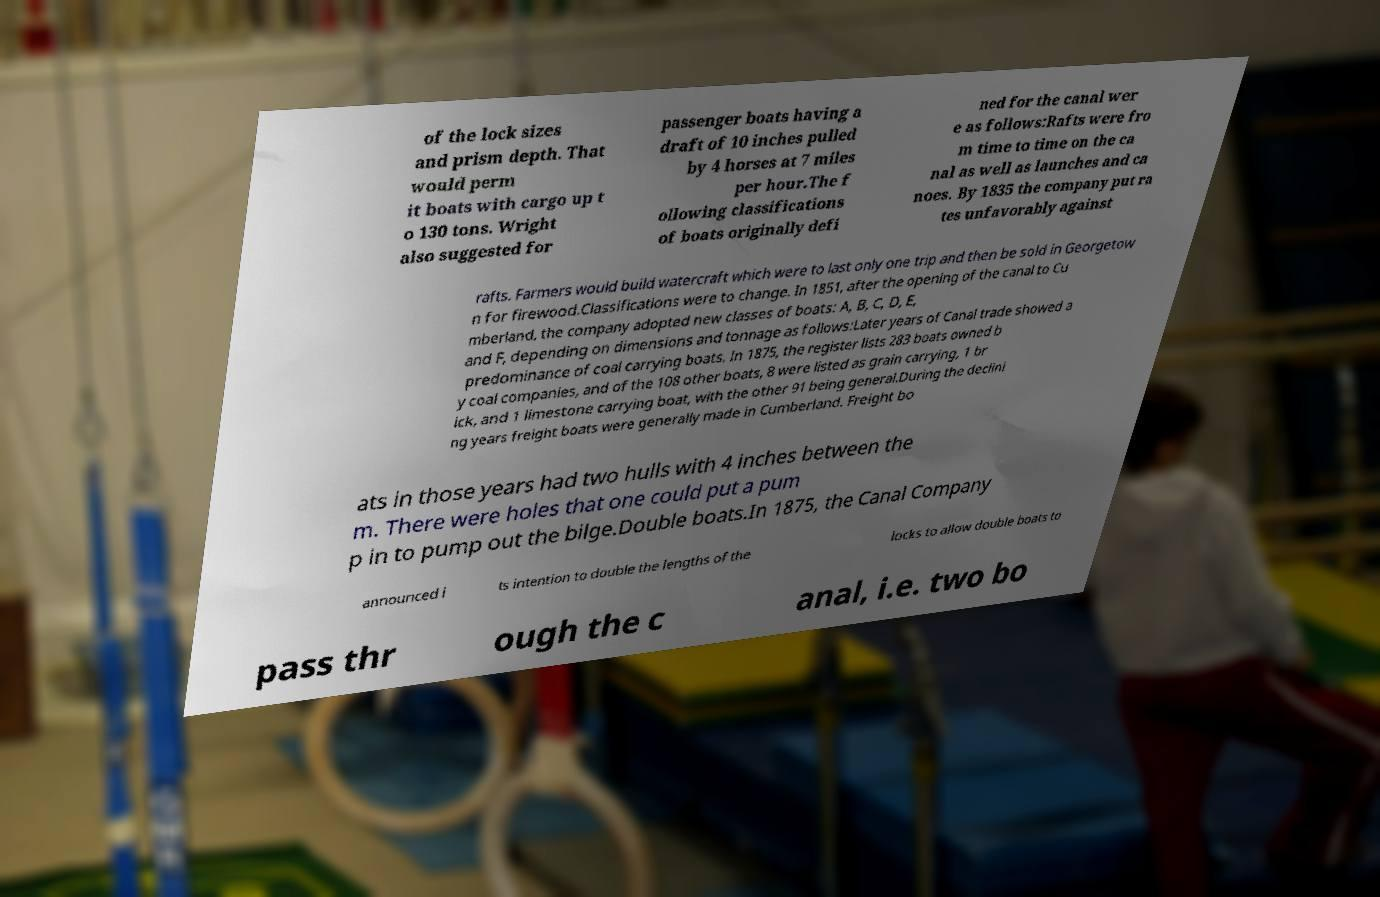Please read and relay the text visible in this image. What does it say? of the lock sizes and prism depth. That would perm it boats with cargo up t o 130 tons. Wright also suggested for passenger boats having a draft of 10 inches pulled by 4 horses at 7 miles per hour.The f ollowing classifications of boats originally defi ned for the canal wer e as follows:Rafts were fro m time to time on the ca nal as well as launches and ca noes. By 1835 the company put ra tes unfavorably against rafts. Farmers would build watercraft which were to last only one trip and then be sold in Georgetow n for firewood.Classifications were to change. In 1851, after the opening of the canal to Cu mberland, the company adopted new classes of boats: A, B, C, D, E, and F, depending on dimensions and tonnage as follows:Later years of Canal trade showed a predominance of coal carrying boats. In 1875, the register lists 283 boats owned b y coal companies, and of the 108 other boats, 8 were listed as grain carrying, 1 br ick, and 1 limestone carrying boat, with the other 91 being general.During the declini ng years freight boats were generally made in Cumberland. Freight bo ats in those years had two hulls with 4 inches between the m. There were holes that one could put a pum p in to pump out the bilge.Double boats.In 1875, the Canal Company announced i ts intention to double the lengths of the locks to allow double boats to pass thr ough the c anal, i.e. two bo 